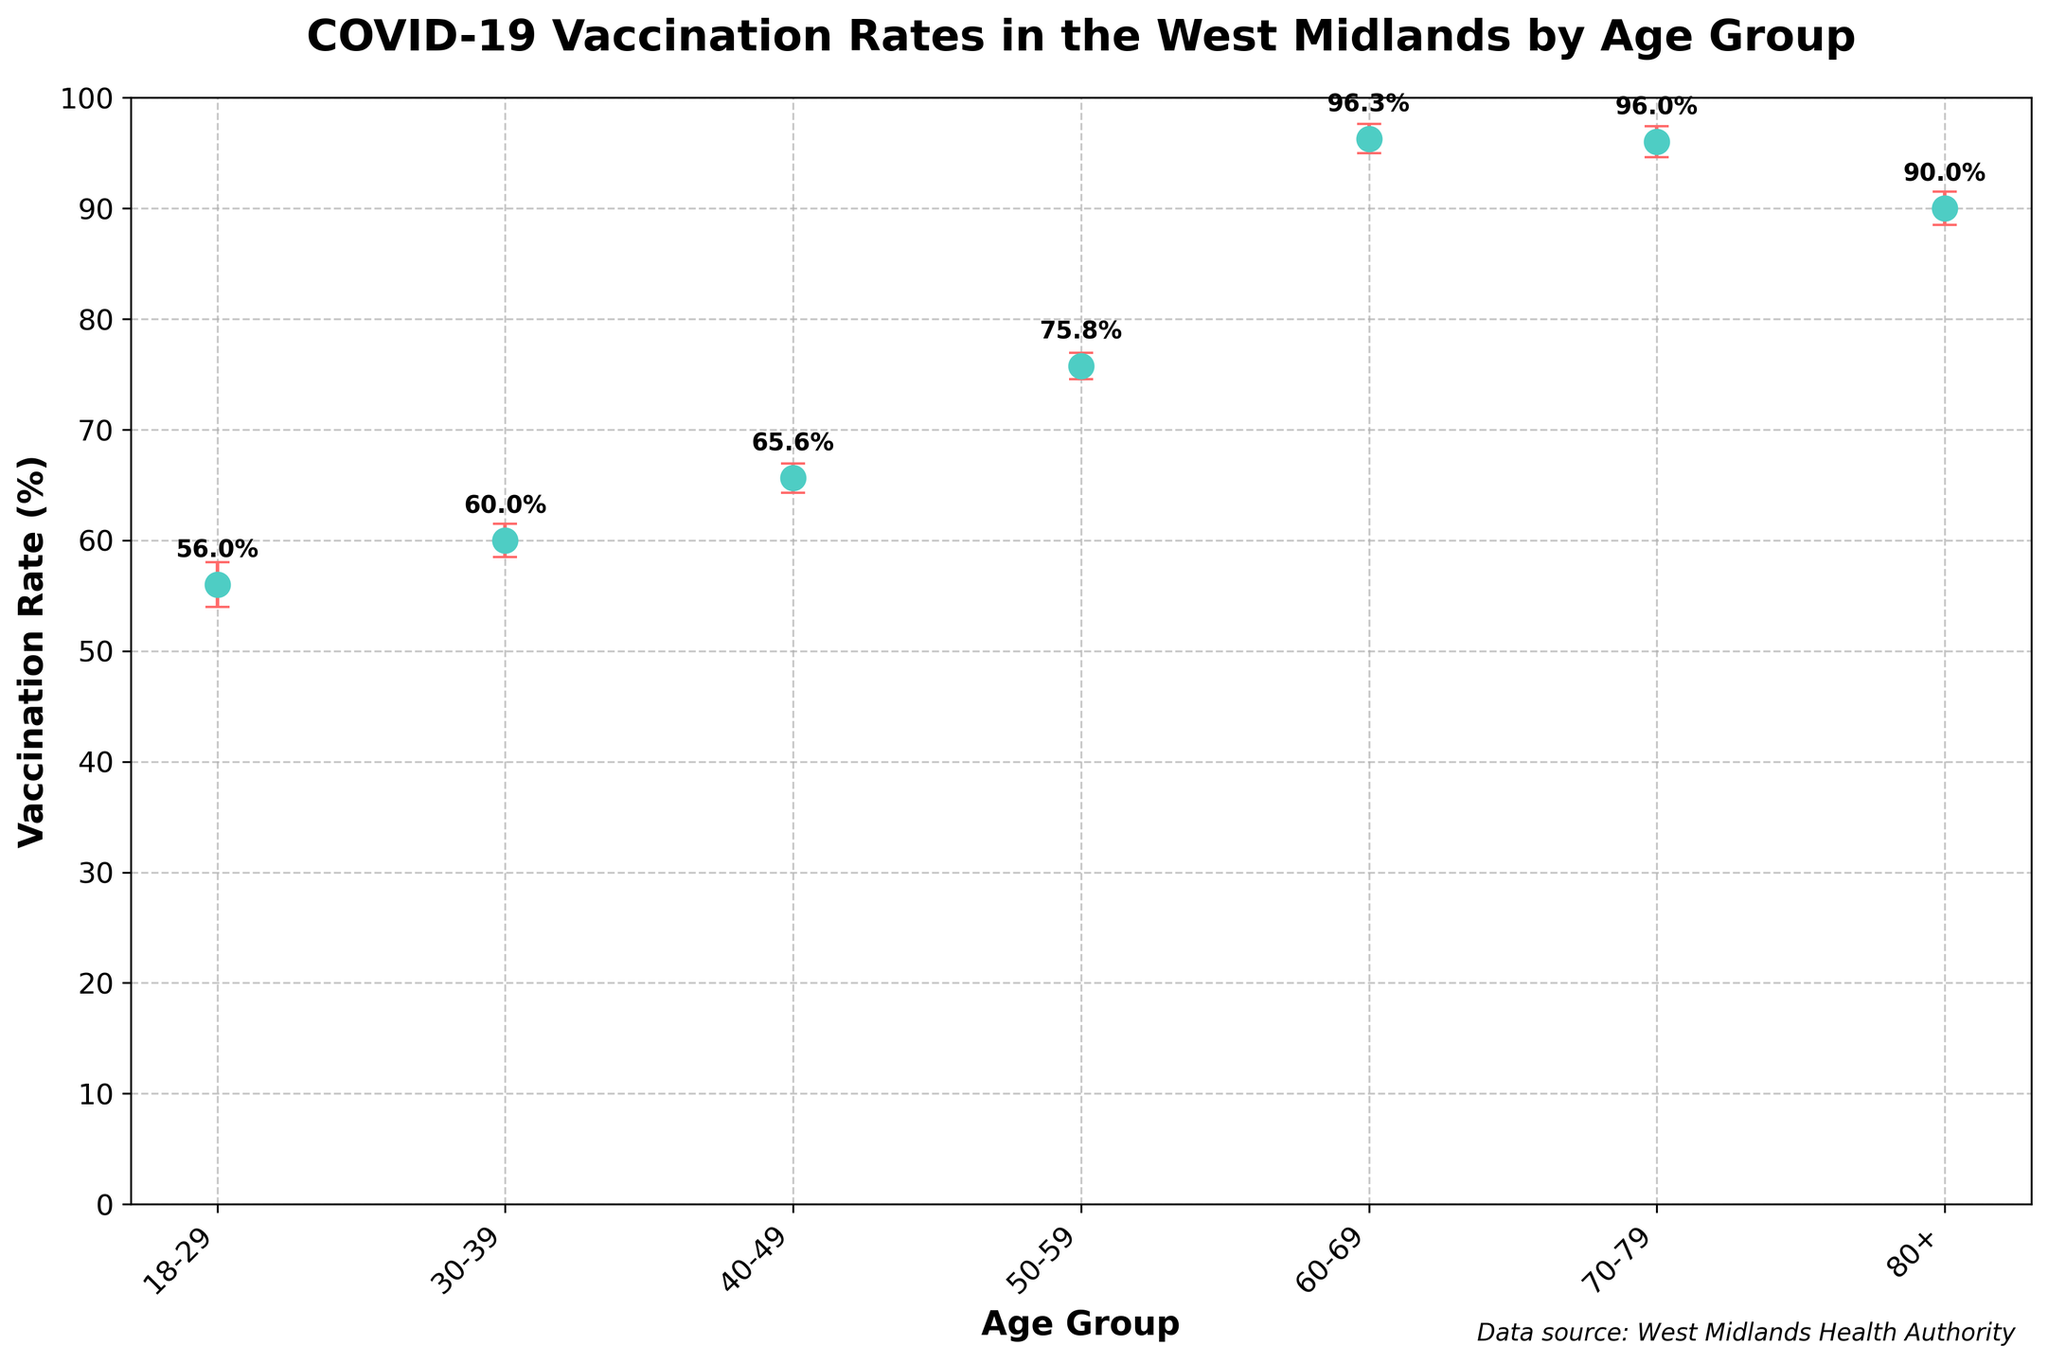What is the title of the chart? The title is typically located at the top of the figure in larger, bold font. Here, the title is 'COVID-19 Vaccination Rates in the West Midlands by Age Group'.
Answer: COVID-19 Vaccination Rates in the West Midlands by Age Group Which age group has the highest vaccination rate? To find the highest vaccination rate, look for the peak value among the plotted points. The age group 60-69 has the highest vaccination rate at just above 96%.
Answer: 60-69 What is the vaccination rate for the age group 50-59? Find the data point corresponding to the age group 50-59. The rate is labeled just above the marker on the plot. It is 75.8%.
Answer: 75.8% What is the error range for the vaccination rate of the 30-39 age group? The error range is represented by the error bars extending from the data point. For 30-39, this error bar extends approximately ±1.5% around the mean value.
Answer: ±1.5% How does the vaccination rate of the 18-29 age group compare to the 70-79 age group? Compare the percentages given next to each age group marker. The 18-29 group has about 56%, while the 70-79 group is around 96%. Therefore, the 70-79 age group has a significantly higher vaccination rate.
Answer: The 70-79 age group is much higher Calculate the difference in vaccination rate between the 40-49 and 80+ age groups. The vaccination rate for 40-49 is about 65.6%, and for 80+ it is 90%. The difference is 90% - 65.6% = 24.4%.
Answer: 24.4% What can we infer from the error bars about the reliability of the vaccination rates between 18-29 and 80+ age groups? The error bars for 18-29 are larger than those for 80+, indicating more variability or less precision in the 18-29 group's vaccine data. This means the estimate for the 18-29 group is less certain.
Answer: Less certain for 18-29, more precise for 80+ Which age group has the smallest standard error, and what does that indicate? The smallest error bar indicates the smallest standard error, which belongs to the 80+ age group. This suggests the vaccination rate for the 80+ age group is determined with higher precision.
Answer: 80+, higher precision 